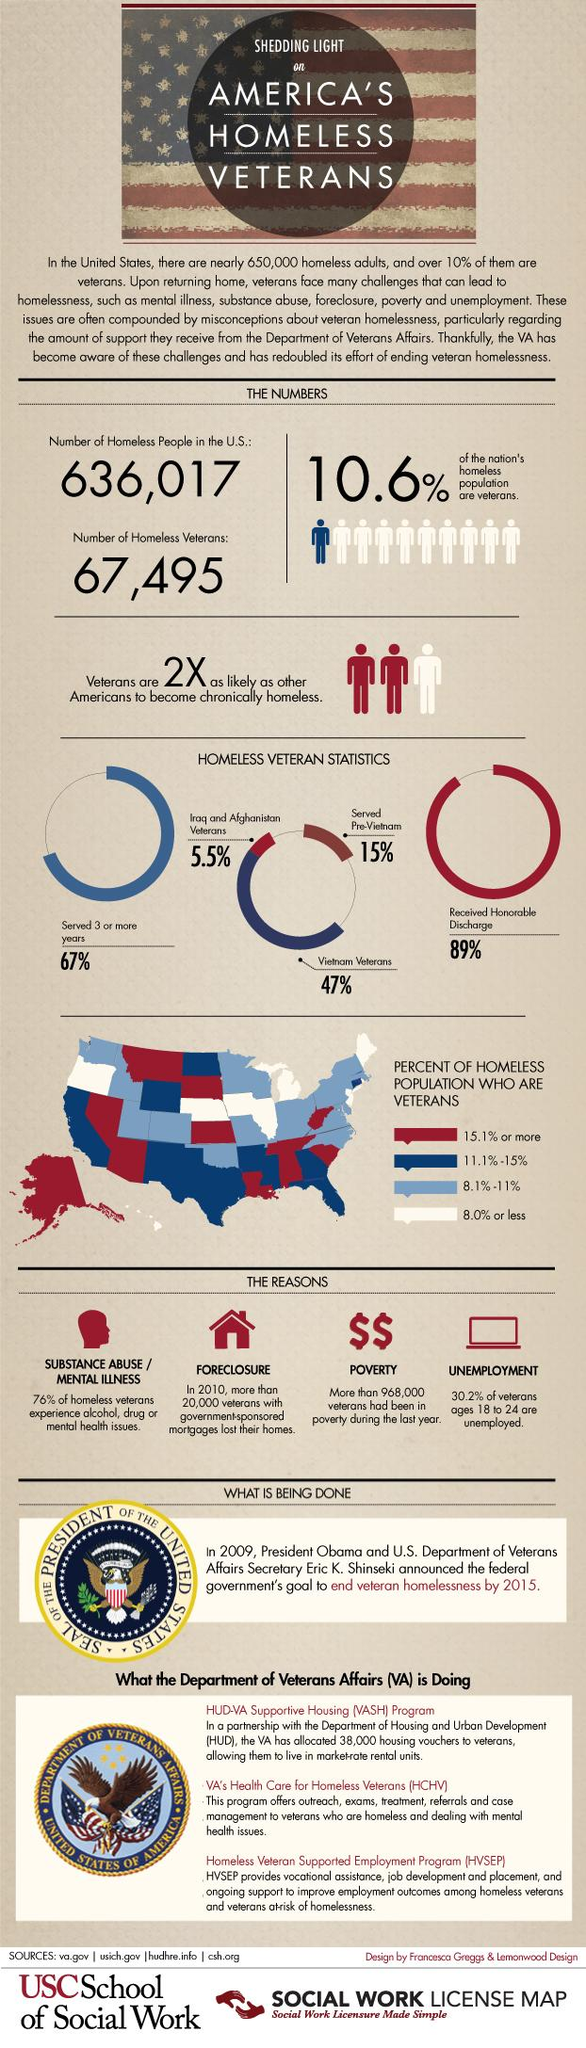Draw attention to some important aspects in this diagram. According to a recent study, 76% of veterans face mental issues or substance abuse. The rate of unemployment among young veterans is 30.2%. In the map, the color white is used to mark the states with less than 8% homeless veterans. 